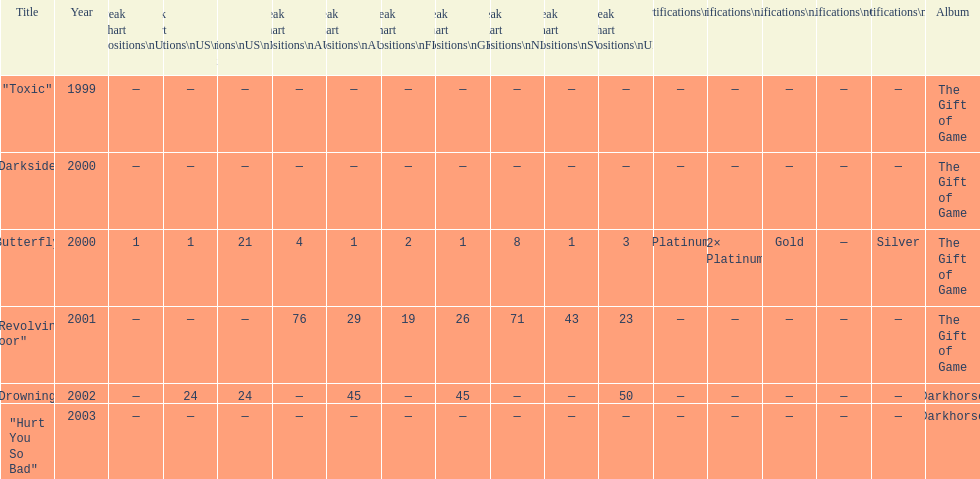When did "drowning" peak at 24 in the us alternate group? 2002. 